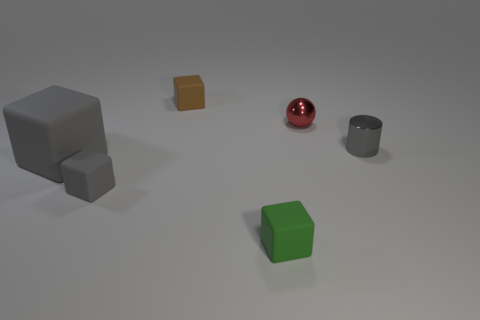How many things are either tiny matte blocks in front of the tiny metallic ball or gray shiny cylinders?
Keep it short and to the point. 3. How big is the gray rubber thing that is in front of the big gray cube?
Offer a very short reply. Small. What is the material of the small gray cube?
Your answer should be very brief. Rubber. What is the shape of the tiny gray object on the left side of the gray object that is right of the small green matte object?
Ensure brevity in your answer.  Cube. How many other objects are there of the same shape as the green thing?
Keep it short and to the point. 3. There is a big gray rubber thing; are there any gray metal cylinders in front of it?
Keep it short and to the point. No. What color is the sphere?
Keep it short and to the point. Red. Is the color of the big rubber object the same as the small rubber thing that is on the left side of the brown cube?
Ensure brevity in your answer.  Yes. Is there another block of the same size as the brown block?
Provide a succinct answer. Yes. There is a tiny gray thing right of the green rubber cube; what material is it?
Your answer should be compact. Metal. 